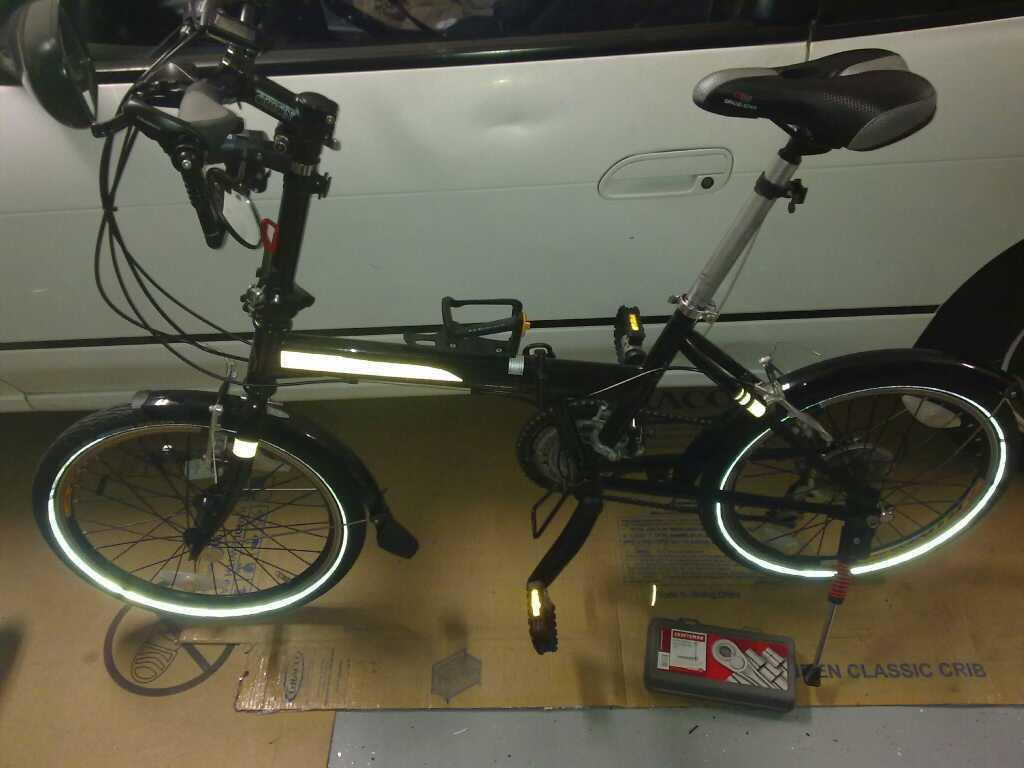Could you give a brief overview of what you see in this image? In this picture, we see bicycle in black color. Beside that, we see a car which is in white color. At the bottom of the picture, we see a plastic box which is in grey and red color. 